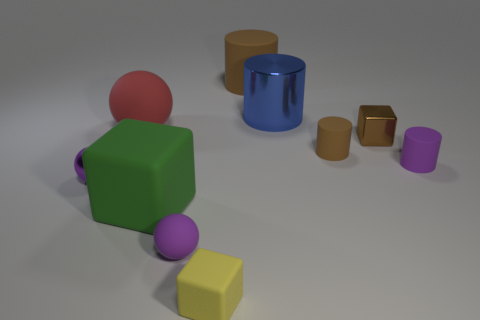What is the size of the blue metallic cylinder? The blue metallic cylinder in the image is medium-sized relative to other objects present, such as the smaller yellow cube and the larger green cube. 